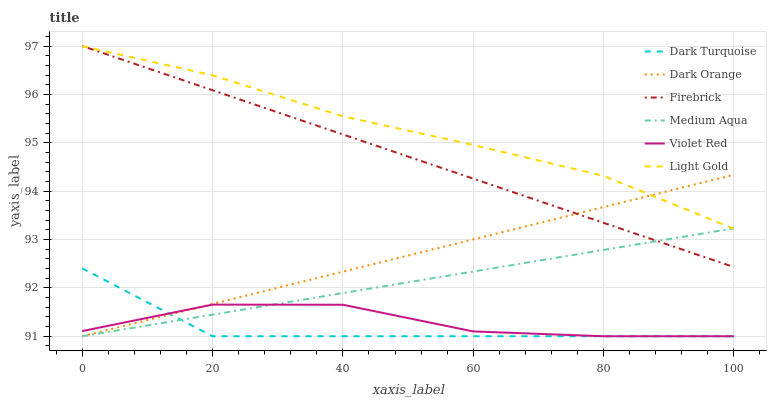Does Dark Turquoise have the minimum area under the curve?
Answer yes or no. Yes. Does Light Gold have the maximum area under the curve?
Answer yes or no. Yes. Does Violet Red have the minimum area under the curve?
Answer yes or no. No. Does Violet Red have the maximum area under the curve?
Answer yes or no. No. Is Medium Aqua the smoothest?
Answer yes or no. Yes. Is Violet Red the roughest?
Answer yes or no. Yes. Is Dark Turquoise the smoothest?
Answer yes or no. No. Is Dark Turquoise the roughest?
Answer yes or no. No. Does Dark Orange have the lowest value?
Answer yes or no. Yes. Does Firebrick have the lowest value?
Answer yes or no. No. Does Firebrick have the highest value?
Answer yes or no. Yes. Does Dark Turquoise have the highest value?
Answer yes or no. No. Is Violet Red less than Light Gold?
Answer yes or no. Yes. Is Light Gold greater than Dark Turquoise?
Answer yes or no. Yes. Does Dark Turquoise intersect Medium Aqua?
Answer yes or no. Yes. Is Dark Turquoise less than Medium Aqua?
Answer yes or no. No. Is Dark Turquoise greater than Medium Aqua?
Answer yes or no. No. Does Violet Red intersect Light Gold?
Answer yes or no. No. 